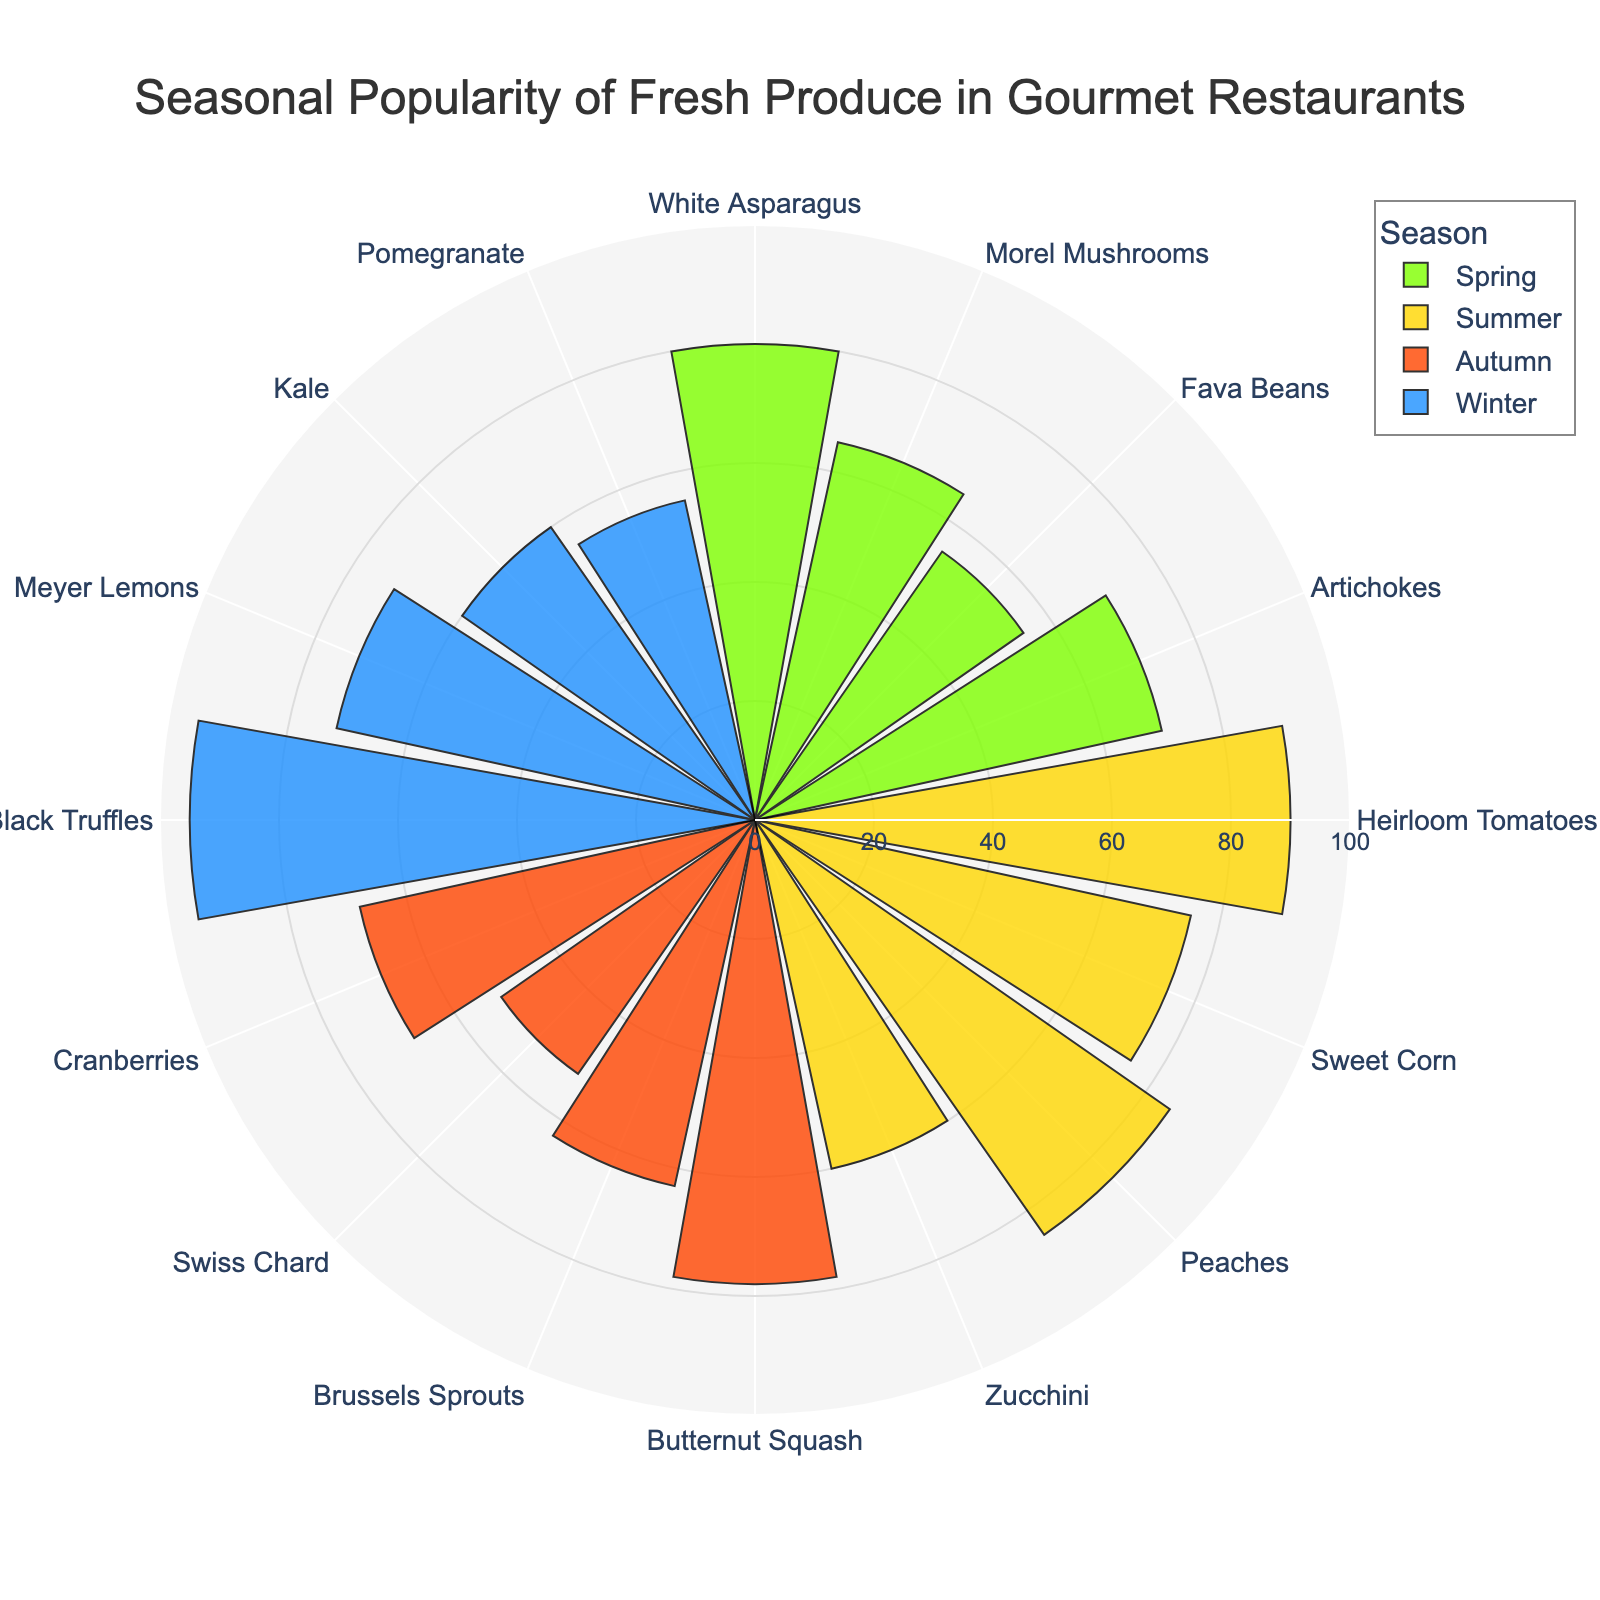What's the title of the figure? At the top of the figure, there's a text box with the title. The title is written in a larger font to stand out.
Answer: Seasonal Popularity of Fresh Produce in Gourmet Restaurants How many different produce items are there in Spring? By counting all the labels associated with Spring in the radial axis, we can determine the number of produce items.
Answer: 4 Which season has the highest popularity for a single produce item? By observing the radial axis and checking the popularity values, we see that Black Truffles in Winter have the highest value.
Answer: Winter What's the average popularity of produce items in Summer? Add the popularity values of Summer produce items and divide by the number of items: (90 + 75 + 85 + 60) / 4.
Answer: 77.5 What produce item has the lowest popularity in Autumn? By comparing the radial axis values for all Autumn produce items, the one with the smallest value is Swiss Chard with a popularity of 52.
Answer: Swiss Chard Compare the popularity of Heirloom Tomatoes and Black Truffles. Which is more popular? By looking at the radial values for both produce items, Heirloom Tomatoes (90) and Black Truffles (95), Black Truffles have a higher value.
Answer: Black Truffles Which two produce items in Winter have the closest popularity values? By examining the radial axis for Winter items, Meyer Lemons (72) and Kale (60), the difference is the smallest among all pairs.
Answer: Meyer Lemons and Kale What's the combined popularity of the most popular produce items from each season? Sum the highest popularity values from each season: Spring (White Asparagus: 80) + Summer (Heirloom Tomatoes: 90) + Autumn (Butternut Squash: 78) + Winter (Black Truffles: 95).
Answer: 343 Which season has the lowest average popularity for its produce items? Calculate the average for each season and compare: Spring: (80+65+55+70)/4 = 67.5; Summer: (90+75+85+60)/4 = 77.5; Autumn: (78+63+52+68)/4 = 65.25; Winter: (95+72+60+55)/4 = 70.5. Autumn has the lowest average.
Answer: Autumn How many seasons have at least one produce item with a popularity above 80? Check the radial axis values for each season to see how many have one or more items above 80: Spring (1), Summer (2), Autumn (0), Winter (1).
Answer: 3 